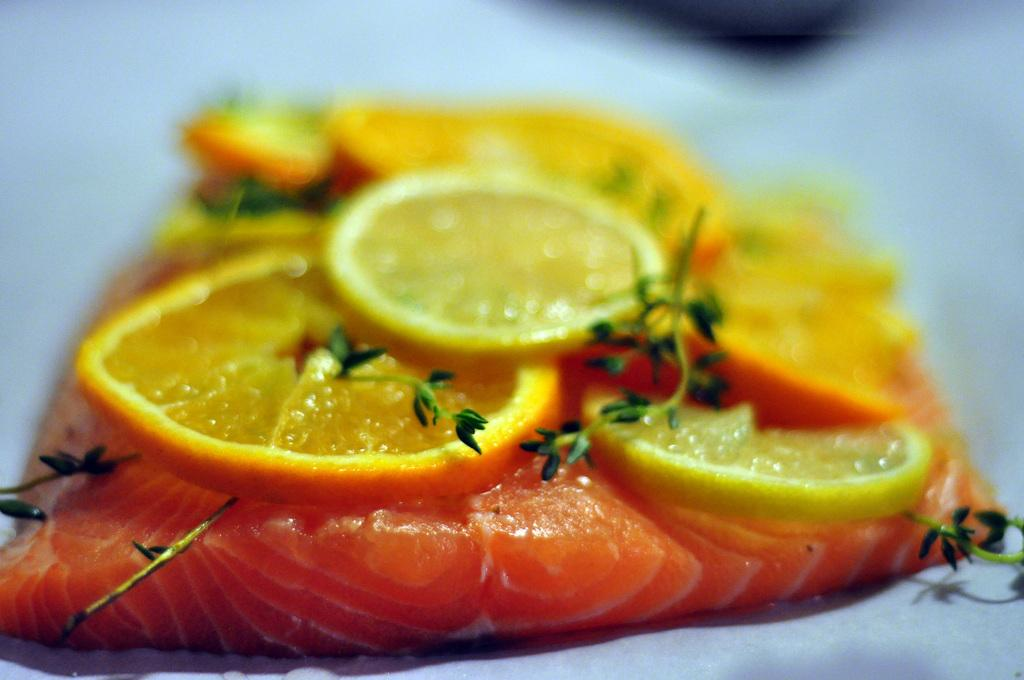What type of food can be seen in the image? There is meat in the image. What other type of food is present in the image? There are slices of a fruit in the image. Can you describe the background of the image? The background of the image is blurry. How many stars can be seen in the image? There are no stars visible in the image. Are there any chickens present in the image? There is no mention of chickens in the image. Can you tell me the age of the grandfather in the image? There is no grandfather present in the image. 